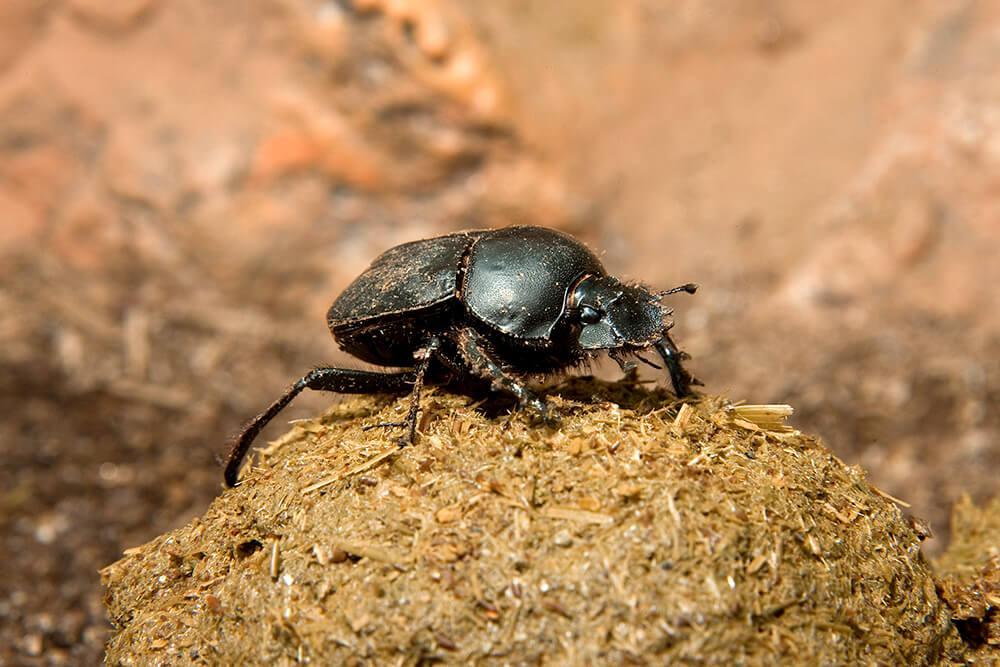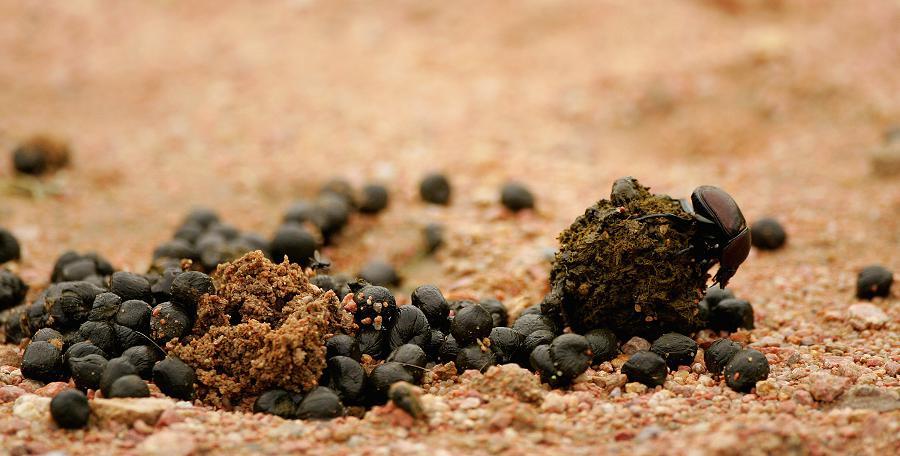The first image is the image on the left, the second image is the image on the right. Assess this claim about the two images: "One image shows one beetle in contact with a round shape, and the other image includes a mass of small dark round things.". Correct or not? Answer yes or no. Yes. 